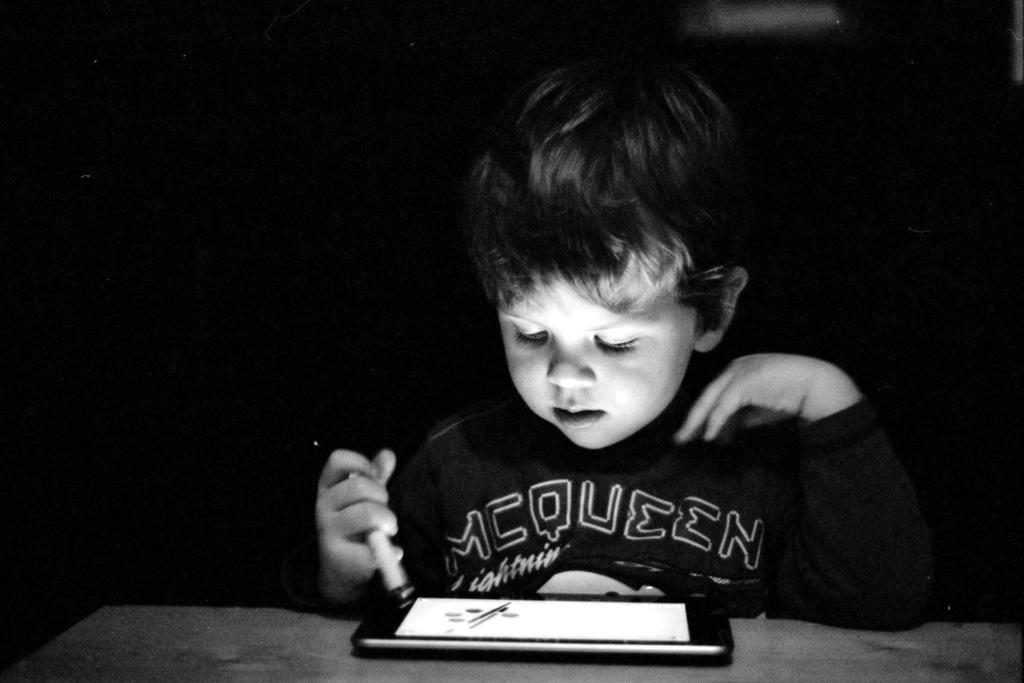Can you describe this image briefly? In this picture there is a boy sitting and looking at the smartphone 